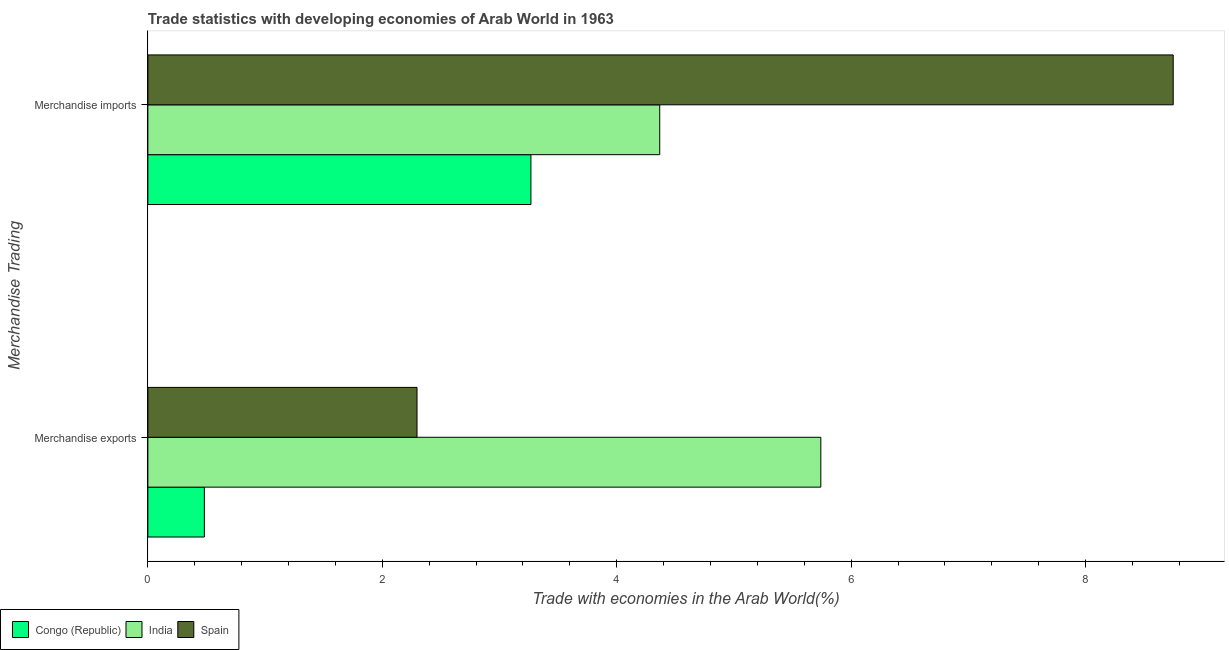How many different coloured bars are there?
Give a very brief answer. 3. Are the number of bars on each tick of the Y-axis equal?
Your response must be concise. Yes. What is the merchandise imports in Spain?
Give a very brief answer. 8.75. Across all countries, what is the maximum merchandise exports?
Provide a succinct answer. 5.74. Across all countries, what is the minimum merchandise imports?
Provide a succinct answer. 3.27. In which country was the merchandise imports maximum?
Provide a short and direct response. Spain. In which country was the merchandise exports minimum?
Offer a very short reply. Congo (Republic). What is the total merchandise imports in the graph?
Make the answer very short. 16.38. What is the difference between the merchandise exports in India and that in Spain?
Make the answer very short. 3.45. What is the difference between the merchandise exports in Spain and the merchandise imports in India?
Keep it short and to the point. -2.07. What is the average merchandise exports per country?
Provide a succinct answer. 2.84. What is the difference between the merchandise imports and merchandise exports in India?
Provide a short and direct response. -1.37. In how many countries, is the merchandise imports greater than 4.8 %?
Provide a short and direct response. 1. What is the ratio of the merchandise imports in Congo (Republic) to that in India?
Ensure brevity in your answer.  0.75. In how many countries, is the merchandise exports greater than the average merchandise exports taken over all countries?
Your answer should be compact. 1. What does the 3rd bar from the top in Merchandise exports represents?
Your answer should be compact. Congo (Republic). What does the 3rd bar from the bottom in Merchandise imports represents?
Your response must be concise. Spain. How many bars are there?
Your response must be concise. 6. How many countries are there in the graph?
Offer a terse response. 3. What is the difference between two consecutive major ticks on the X-axis?
Keep it short and to the point. 2. Are the values on the major ticks of X-axis written in scientific E-notation?
Keep it short and to the point. No. Does the graph contain any zero values?
Give a very brief answer. No. What is the title of the graph?
Give a very brief answer. Trade statistics with developing economies of Arab World in 1963. Does "Kenya" appear as one of the legend labels in the graph?
Provide a short and direct response. No. What is the label or title of the X-axis?
Give a very brief answer. Trade with economies in the Arab World(%). What is the label or title of the Y-axis?
Your answer should be very brief. Merchandise Trading. What is the Trade with economies in the Arab World(%) of Congo (Republic) in Merchandise exports?
Keep it short and to the point. 0.48. What is the Trade with economies in the Arab World(%) of India in Merchandise exports?
Keep it short and to the point. 5.74. What is the Trade with economies in the Arab World(%) of Spain in Merchandise exports?
Your response must be concise. 2.3. What is the Trade with economies in the Arab World(%) of Congo (Republic) in Merchandise imports?
Make the answer very short. 3.27. What is the Trade with economies in the Arab World(%) in India in Merchandise imports?
Keep it short and to the point. 4.37. What is the Trade with economies in the Arab World(%) in Spain in Merchandise imports?
Give a very brief answer. 8.75. Across all Merchandise Trading, what is the maximum Trade with economies in the Arab World(%) in Congo (Republic)?
Offer a terse response. 3.27. Across all Merchandise Trading, what is the maximum Trade with economies in the Arab World(%) in India?
Your response must be concise. 5.74. Across all Merchandise Trading, what is the maximum Trade with economies in the Arab World(%) of Spain?
Your response must be concise. 8.75. Across all Merchandise Trading, what is the minimum Trade with economies in the Arab World(%) in Congo (Republic)?
Your response must be concise. 0.48. Across all Merchandise Trading, what is the minimum Trade with economies in the Arab World(%) of India?
Offer a terse response. 4.37. Across all Merchandise Trading, what is the minimum Trade with economies in the Arab World(%) of Spain?
Offer a terse response. 2.3. What is the total Trade with economies in the Arab World(%) in Congo (Republic) in the graph?
Provide a succinct answer. 3.75. What is the total Trade with economies in the Arab World(%) in India in the graph?
Your answer should be very brief. 10.11. What is the total Trade with economies in the Arab World(%) in Spain in the graph?
Offer a terse response. 11.04. What is the difference between the Trade with economies in the Arab World(%) in Congo (Republic) in Merchandise exports and that in Merchandise imports?
Offer a terse response. -2.79. What is the difference between the Trade with economies in the Arab World(%) in India in Merchandise exports and that in Merchandise imports?
Make the answer very short. 1.37. What is the difference between the Trade with economies in the Arab World(%) in Spain in Merchandise exports and that in Merchandise imports?
Offer a very short reply. -6.45. What is the difference between the Trade with economies in the Arab World(%) of Congo (Republic) in Merchandise exports and the Trade with economies in the Arab World(%) of India in Merchandise imports?
Ensure brevity in your answer.  -3.88. What is the difference between the Trade with economies in the Arab World(%) in Congo (Republic) in Merchandise exports and the Trade with economies in the Arab World(%) in Spain in Merchandise imports?
Give a very brief answer. -8.27. What is the difference between the Trade with economies in the Arab World(%) in India in Merchandise exports and the Trade with economies in the Arab World(%) in Spain in Merchandise imports?
Keep it short and to the point. -3.01. What is the average Trade with economies in the Arab World(%) in Congo (Republic) per Merchandise Trading?
Ensure brevity in your answer.  1.88. What is the average Trade with economies in the Arab World(%) in India per Merchandise Trading?
Your answer should be very brief. 5.05. What is the average Trade with economies in the Arab World(%) in Spain per Merchandise Trading?
Your answer should be compact. 5.52. What is the difference between the Trade with economies in the Arab World(%) of Congo (Republic) and Trade with economies in the Arab World(%) of India in Merchandise exports?
Offer a very short reply. -5.26. What is the difference between the Trade with economies in the Arab World(%) of Congo (Republic) and Trade with economies in the Arab World(%) of Spain in Merchandise exports?
Provide a succinct answer. -1.81. What is the difference between the Trade with economies in the Arab World(%) in India and Trade with economies in the Arab World(%) in Spain in Merchandise exports?
Make the answer very short. 3.45. What is the difference between the Trade with economies in the Arab World(%) in Congo (Republic) and Trade with economies in the Arab World(%) in India in Merchandise imports?
Ensure brevity in your answer.  -1.1. What is the difference between the Trade with economies in the Arab World(%) in Congo (Republic) and Trade with economies in the Arab World(%) in Spain in Merchandise imports?
Your response must be concise. -5.48. What is the difference between the Trade with economies in the Arab World(%) in India and Trade with economies in the Arab World(%) in Spain in Merchandise imports?
Ensure brevity in your answer.  -4.38. What is the ratio of the Trade with economies in the Arab World(%) in Congo (Republic) in Merchandise exports to that in Merchandise imports?
Keep it short and to the point. 0.15. What is the ratio of the Trade with economies in the Arab World(%) of India in Merchandise exports to that in Merchandise imports?
Provide a short and direct response. 1.31. What is the ratio of the Trade with economies in the Arab World(%) of Spain in Merchandise exports to that in Merchandise imports?
Ensure brevity in your answer.  0.26. What is the difference between the highest and the second highest Trade with economies in the Arab World(%) in Congo (Republic)?
Make the answer very short. 2.79. What is the difference between the highest and the second highest Trade with economies in the Arab World(%) of India?
Keep it short and to the point. 1.37. What is the difference between the highest and the second highest Trade with economies in the Arab World(%) of Spain?
Your answer should be very brief. 6.45. What is the difference between the highest and the lowest Trade with economies in the Arab World(%) of Congo (Republic)?
Provide a short and direct response. 2.79. What is the difference between the highest and the lowest Trade with economies in the Arab World(%) in India?
Your response must be concise. 1.37. What is the difference between the highest and the lowest Trade with economies in the Arab World(%) of Spain?
Provide a short and direct response. 6.45. 